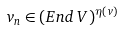<formula> <loc_0><loc_0><loc_500><loc_500>v _ { n } \in ( E n d \, V ) ^ { \eta ( v ) }</formula> 